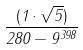<formula> <loc_0><loc_0><loc_500><loc_500>\frac { ( 1 \cdot \sqrt { 5 } ) } { 2 8 0 - 9 ^ { 3 9 8 } }</formula> 